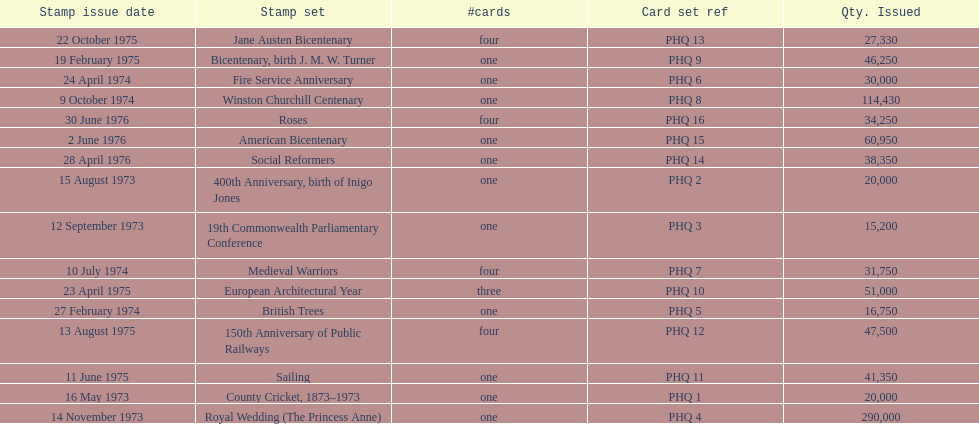Which stamp set had only three cards in the set? European Architectural Year. 